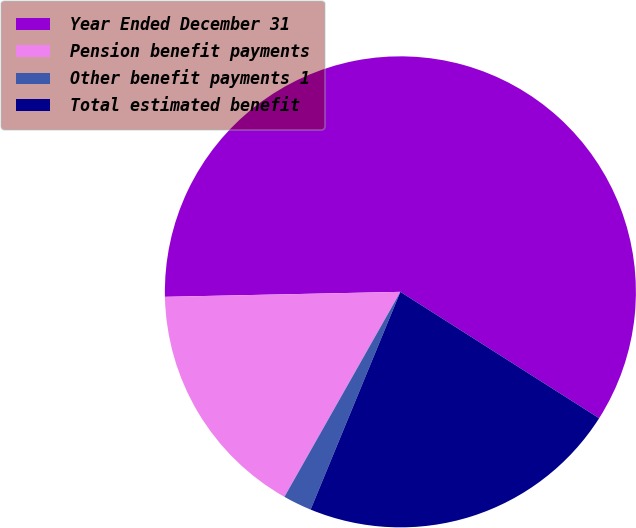Convert chart to OTSL. <chart><loc_0><loc_0><loc_500><loc_500><pie_chart><fcel>Year Ended December 31<fcel>Pension benefit payments<fcel>Other benefit payments 1<fcel>Total estimated benefit<nl><fcel>59.35%<fcel>16.47%<fcel>1.97%<fcel>22.21%<nl></chart> 